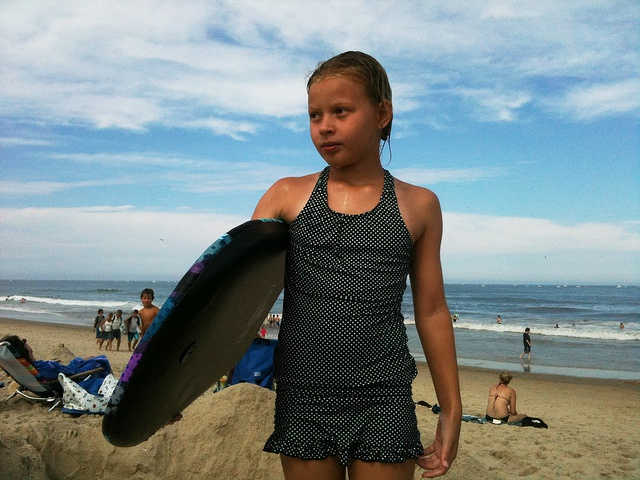Describe the objects in this image and their specific colors. I can see people in lightgray, black, maroon, gray, and brown tones, surfboard in lightgray, black, blue, navy, and purple tones, people in lightgray, black, gray, darkgray, and tan tones, chair in lightgray, black, gray, and maroon tones, and chair in lightgray, navy, black, gray, and tan tones in this image. 